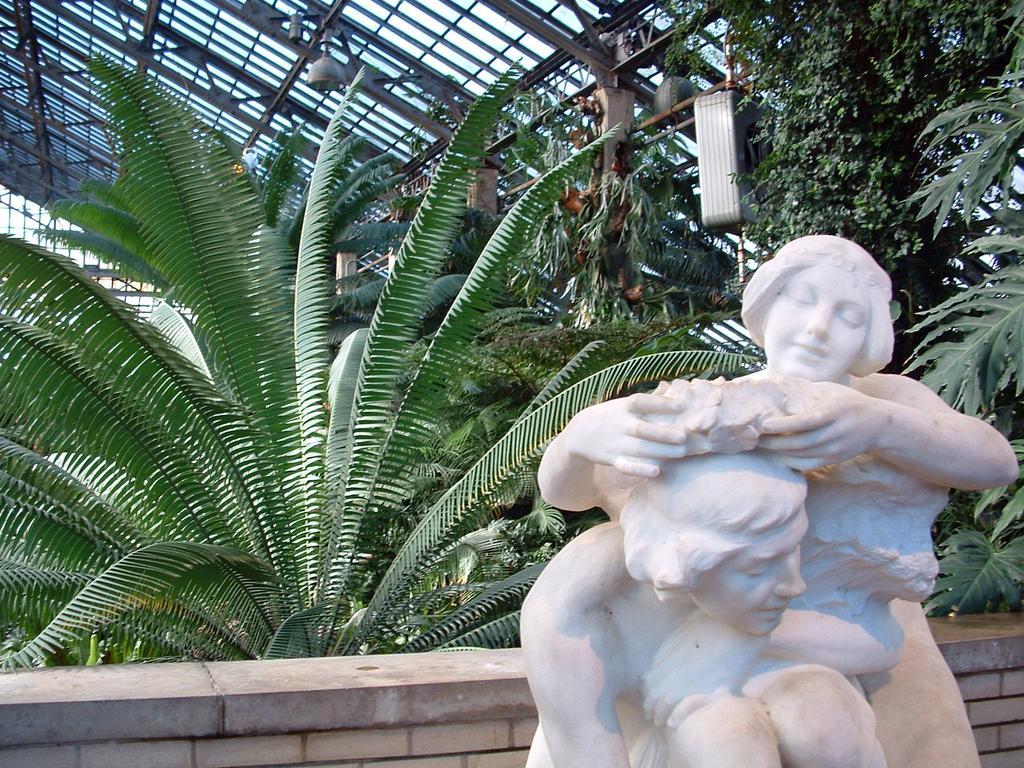Please provide a concise description of this image. In this image on the right side we can see statues of two persons. In the background we can see plants, wall, glass roof, lights on the poles and objects. 